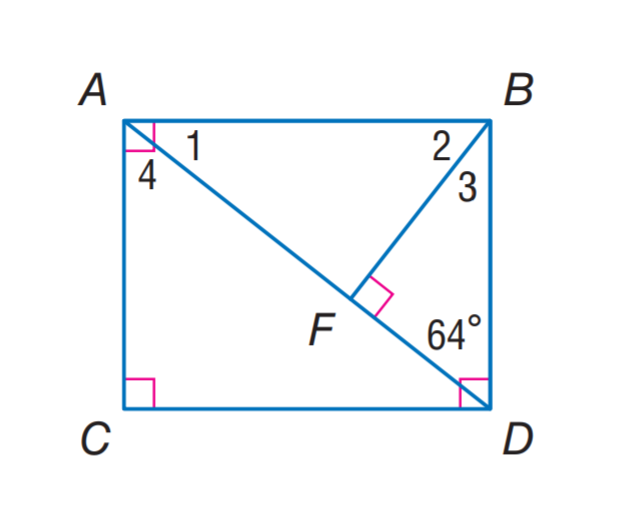Answer the mathemtical geometry problem and directly provide the correct option letter.
Question: Find m \angle 1.
Choices: A: 26 B: 32 C: 58 D: 64 A 